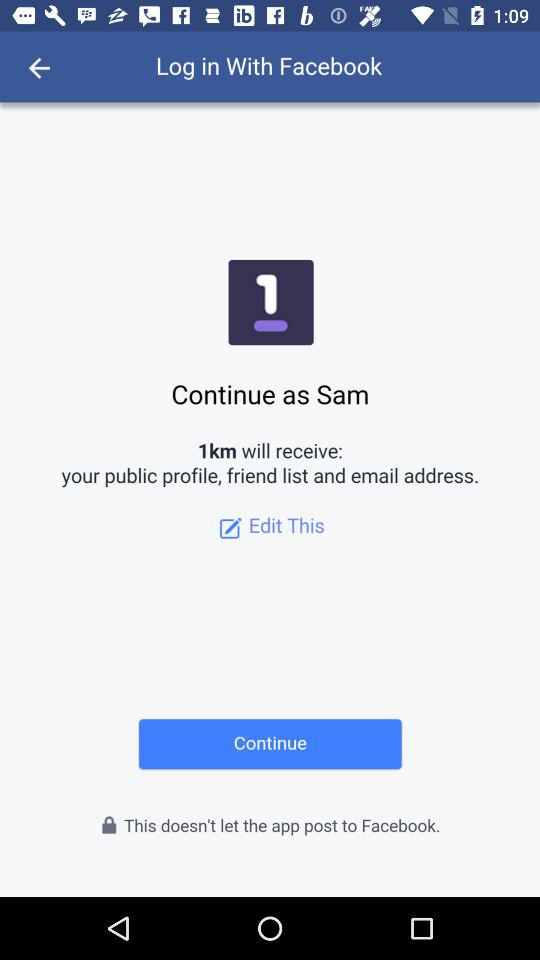What applications can be used to log in into the profile? You can log in with "Facebook". 